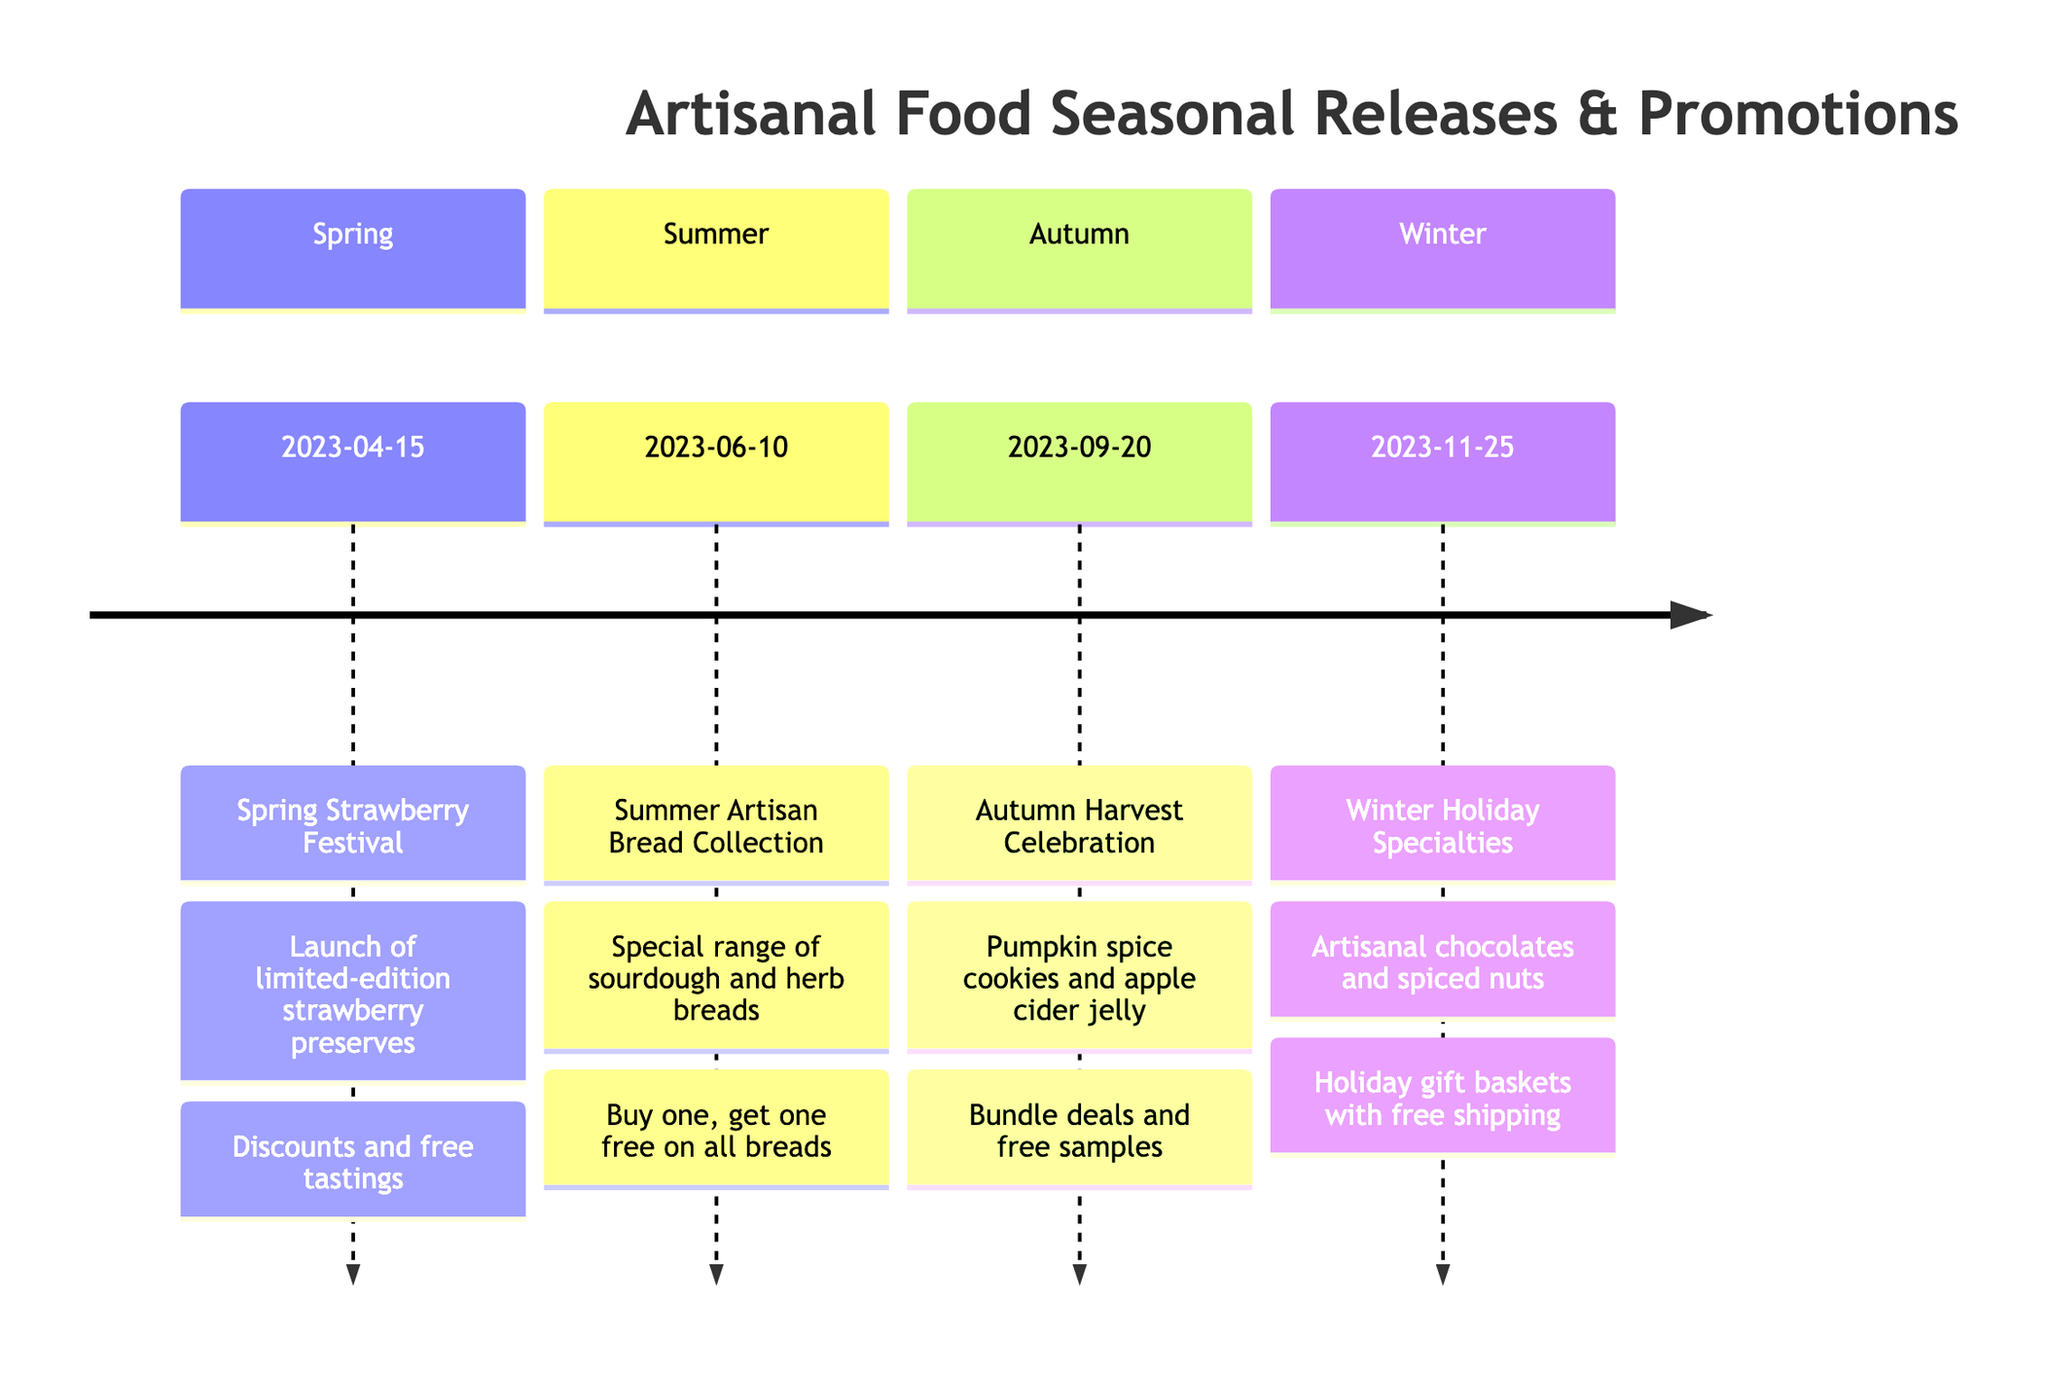What is the key date for the Spring Strawberry Festival? The key date is found in the Spring section under the event name "Spring Strawberry Festival," which states "2023-04-15."
Answer: 2023-04-15 How many seasonal releases are listed in the timeline? To determine the number, count the number of sections in the timeline. There are four sections: Spring, Summer, Autumn, and Winter, each containing one release.
Answer: 4 What type of products are launched during the Autumn Harvest Celebration? The Autumn section describes the products as "pumpkin spice cookies and apple cider jelly."
Answer: pumpkin spice cookies and apple cider jelly What promotion is offered for the Summer Artisan Bread Collection? The promotion is mentioned in the Summer section which states "Buy one, get one free on all breads during the first week."
Answer: Buy one, get one free on all breads Which event has a launch date closest to the end of the year? To find this, the dates are compared. The Winter Holiday Specialties event is on "2023-11-25," which is the latest date of all listed events.
Answer: Winter Holiday Specialties What is the main product associated with the Winter Holiday Specialties? The Winter section indicates that "artisanal chocolates and spiced nuts" are the main products associated with this event.
Answer: artisanal chocolates and spiced nuts What special offer is available for the Winter Holiday Specialties? The Winter section states, "Holiday gift baskets at a special price, with free shipping for orders over $50," indicating the special offer.
Answer: Holiday gift baskets at a special price, with free shipping for orders over $50 What date marks the beginning of the Summer Artisan Bread Collection? The Summer section shows the key date as "2023-06-10," marking the beginning of this collection.
Answer: 2023-06-10 Which seasonal event offers free samples throughout the month? The Autumn Harvest Celebration offers free samples as indicated in its promotion details, specifically stating "free samples available throughout the month."
Answer: Autumn Harvest Celebration 